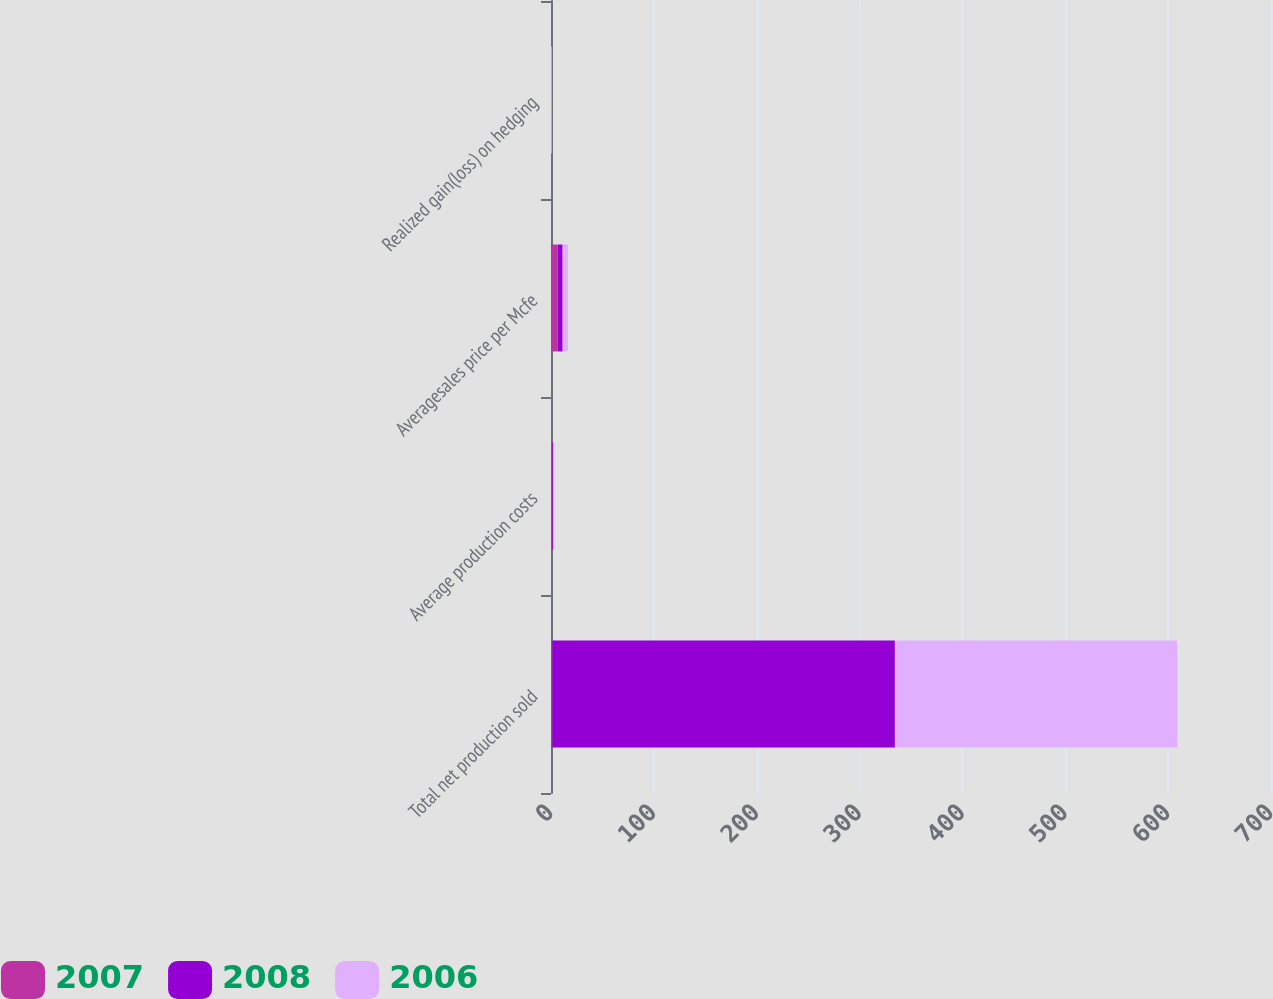Convert chart. <chart><loc_0><loc_0><loc_500><loc_500><stacked_bar_chart><ecel><fcel>Total net production sold<fcel>Average production costs<fcel>Averagesales price per Mcfe<fcel>Realized gain(loss) on hedging<nl><fcel>2007<fcel>1.26<fcel>1.26<fcel>6.39<fcel>0.09<nl><fcel>2008<fcel>333.1<fcel>0.98<fcel>4.92<fcel>0.16<nl><fcel>2006<fcel>274.4<fcel>1.02<fcel>5.24<fcel>0.73<nl></chart> 